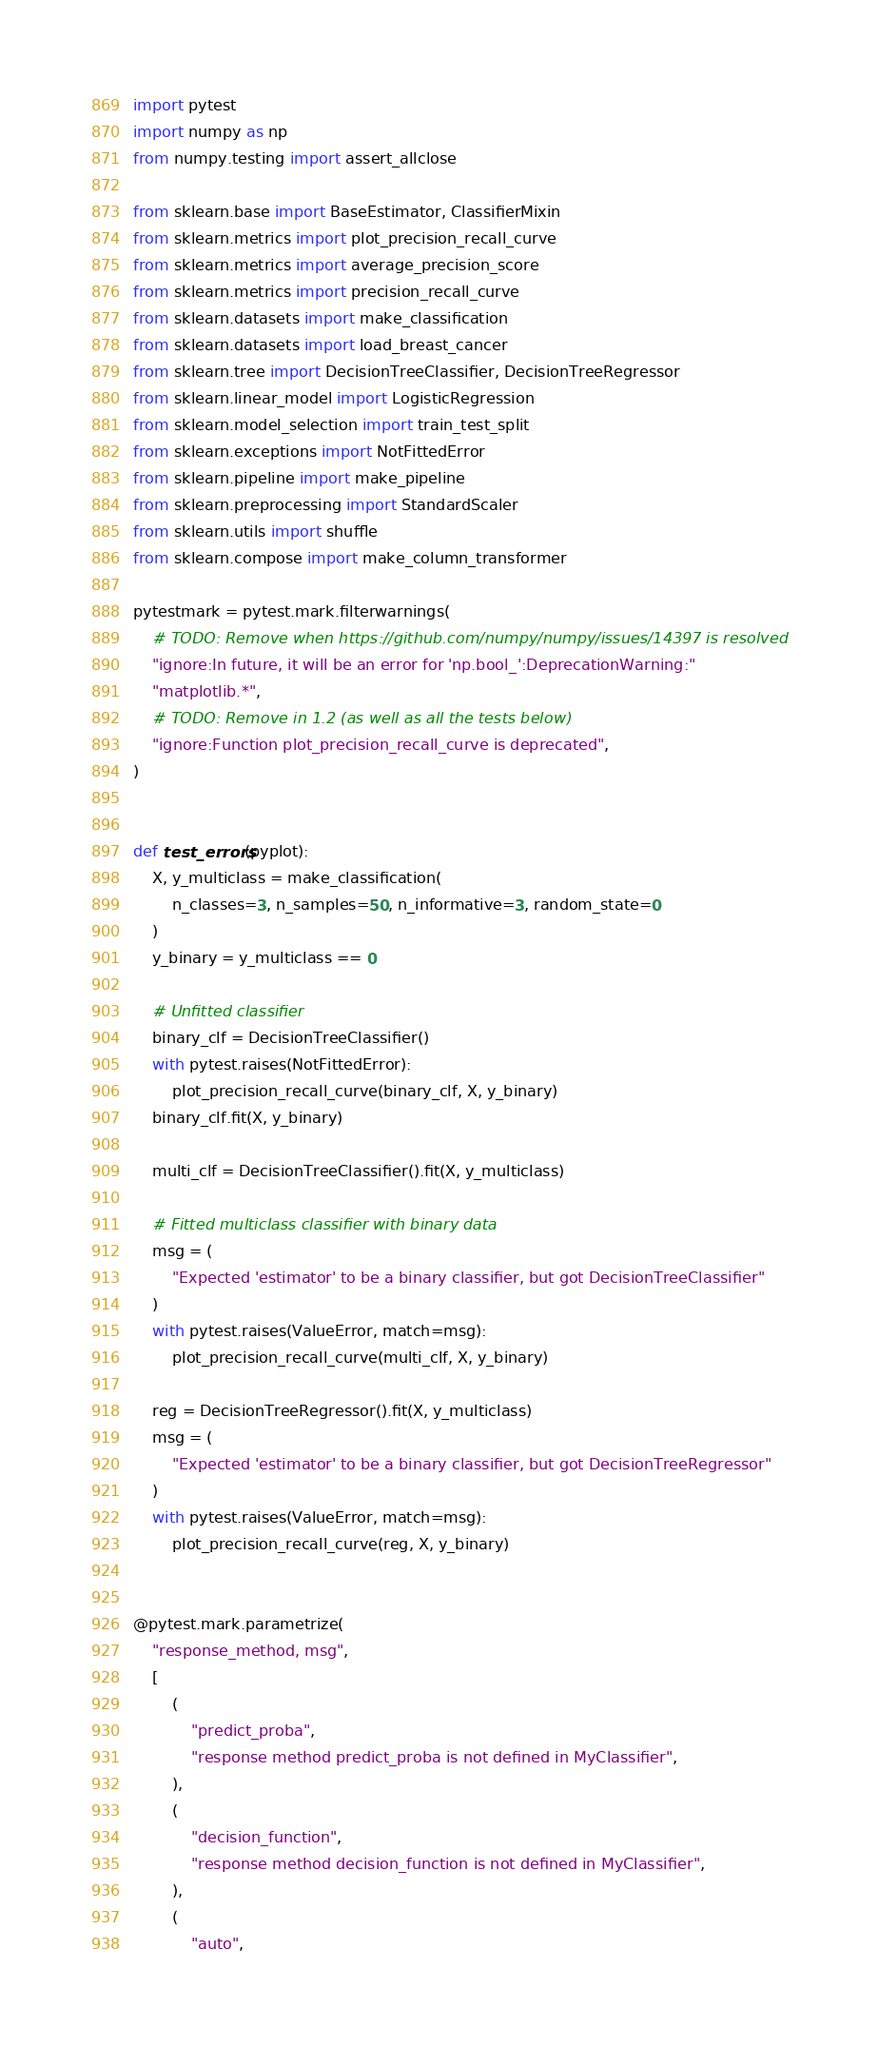Convert code to text. <code><loc_0><loc_0><loc_500><loc_500><_Python_>import pytest
import numpy as np
from numpy.testing import assert_allclose

from sklearn.base import BaseEstimator, ClassifierMixin
from sklearn.metrics import plot_precision_recall_curve
from sklearn.metrics import average_precision_score
from sklearn.metrics import precision_recall_curve
from sklearn.datasets import make_classification
from sklearn.datasets import load_breast_cancer
from sklearn.tree import DecisionTreeClassifier, DecisionTreeRegressor
from sklearn.linear_model import LogisticRegression
from sklearn.model_selection import train_test_split
from sklearn.exceptions import NotFittedError
from sklearn.pipeline import make_pipeline
from sklearn.preprocessing import StandardScaler
from sklearn.utils import shuffle
from sklearn.compose import make_column_transformer

pytestmark = pytest.mark.filterwarnings(
    # TODO: Remove when https://github.com/numpy/numpy/issues/14397 is resolved
    "ignore:In future, it will be an error for 'np.bool_':DeprecationWarning:"
    "matplotlib.*",
    # TODO: Remove in 1.2 (as well as all the tests below)
    "ignore:Function plot_precision_recall_curve is deprecated",
)


def test_errors(pyplot):
    X, y_multiclass = make_classification(
        n_classes=3, n_samples=50, n_informative=3, random_state=0
    )
    y_binary = y_multiclass == 0

    # Unfitted classifier
    binary_clf = DecisionTreeClassifier()
    with pytest.raises(NotFittedError):
        plot_precision_recall_curve(binary_clf, X, y_binary)
    binary_clf.fit(X, y_binary)

    multi_clf = DecisionTreeClassifier().fit(X, y_multiclass)

    # Fitted multiclass classifier with binary data
    msg = (
        "Expected 'estimator' to be a binary classifier, but got DecisionTreeClassifier"
    )
    with pytest.raises(ValueError, match=msg):
        plot_precision_recall_curve(multi_clf, X, y_binary)

    reg = DecisionTreeRegressor().fit(X, y_multiclass)
    msg = (
        "Expected 'estimator' to be a binary classifier, but got DecisionTreeRegressor"
    )
    with pytest.raises(ValueError, match=msg):
        plot_precision_recall_curve(reg, X, y_binary)


@pytest.mark.parametrize(
    "response_method, msg",
    [
        (
            "predict_proba",
            "response method predict_proba is not defined in MyClassifier",
        ),
        (
            "decision_function",
            "response method decision_function is not defined in MyClassifier",
        ),
        (
            "auto",</code> 